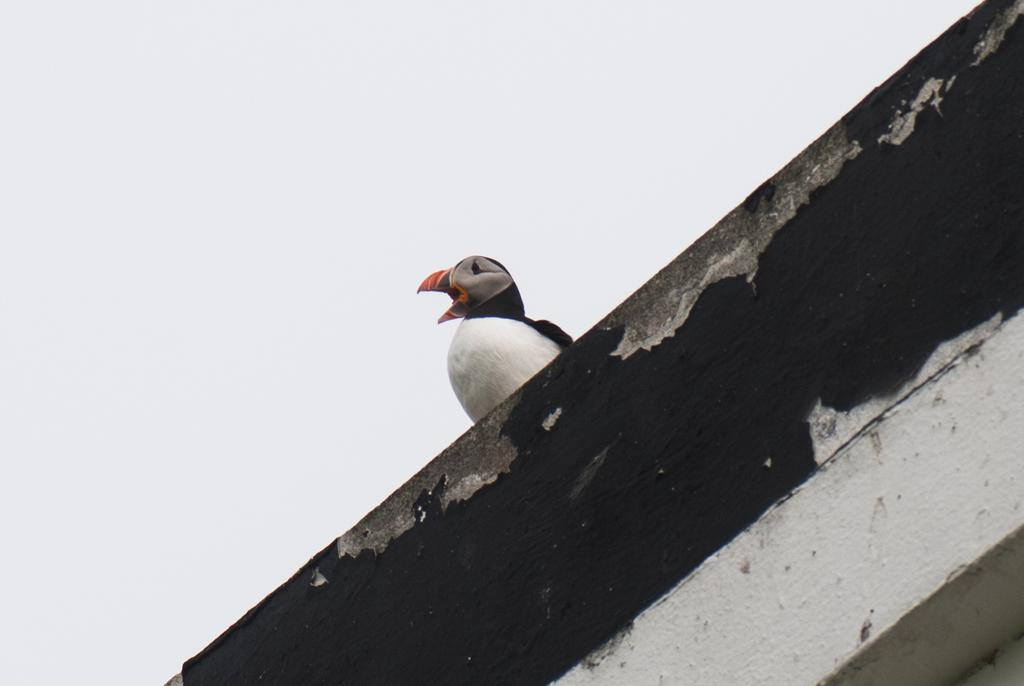What type of animal can be seen on the wall in the image? There is a bird on the wall in the image. What part of the natural environment is visible in the image? The sky is visible at the top of the image. How many worms can be seen crawling on the bird's legs in the image? There are no worms or legs visible in the image, as it features a bird on the wall with the sky in the background. 